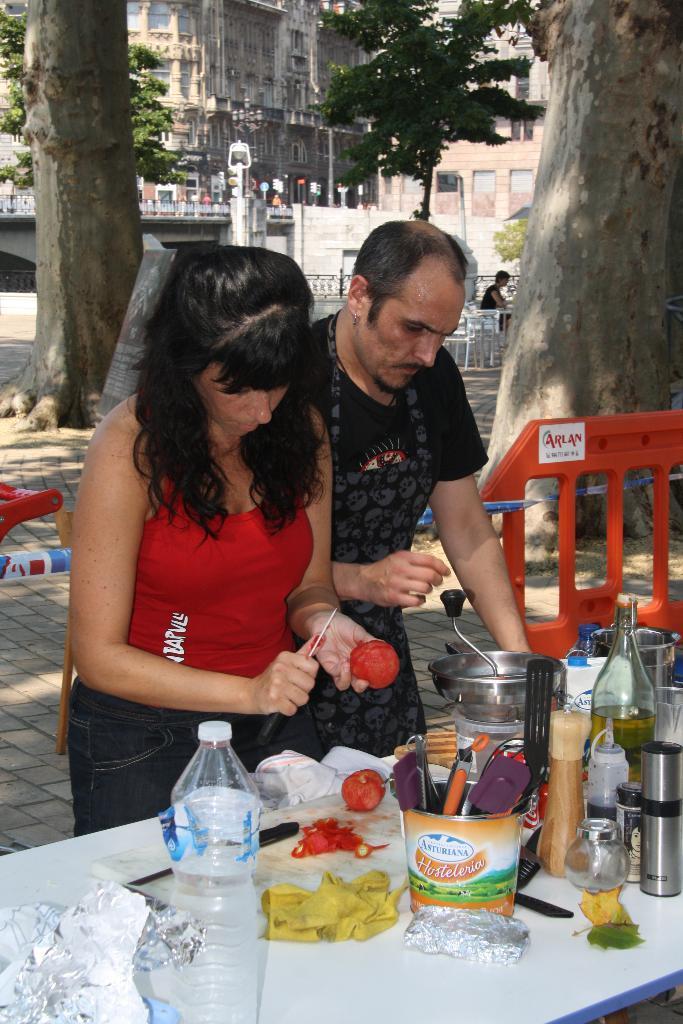Please provide a concise description of this image. In this picture there is a woman and a man the woman is peeling the tomato and the man is standing by resting his hand on the table, there are some bottles and spoons are placed on the table it relates to the kitchenware and there is a barricade at the right side of the image behind the man, there are some trees behind the area of the people, there is a building at the top side of the image. 